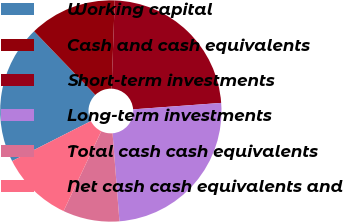<chart> <loc_0><loc_0><loc_500><loc_500><pie_chart><fcel>Working capital<fcel>Cash and cash equivalents<fcel>Short-term investments<fcel>Long-term investments<fcel>Total cash cash equivalents<fcel>Net cash cash equivalents and<nl><fcel>20.27%<fcel>12.76%<fcel>23.27%<fcel>24.92%<fcel>8.26%<fcel>10.51%<nl></chart> 